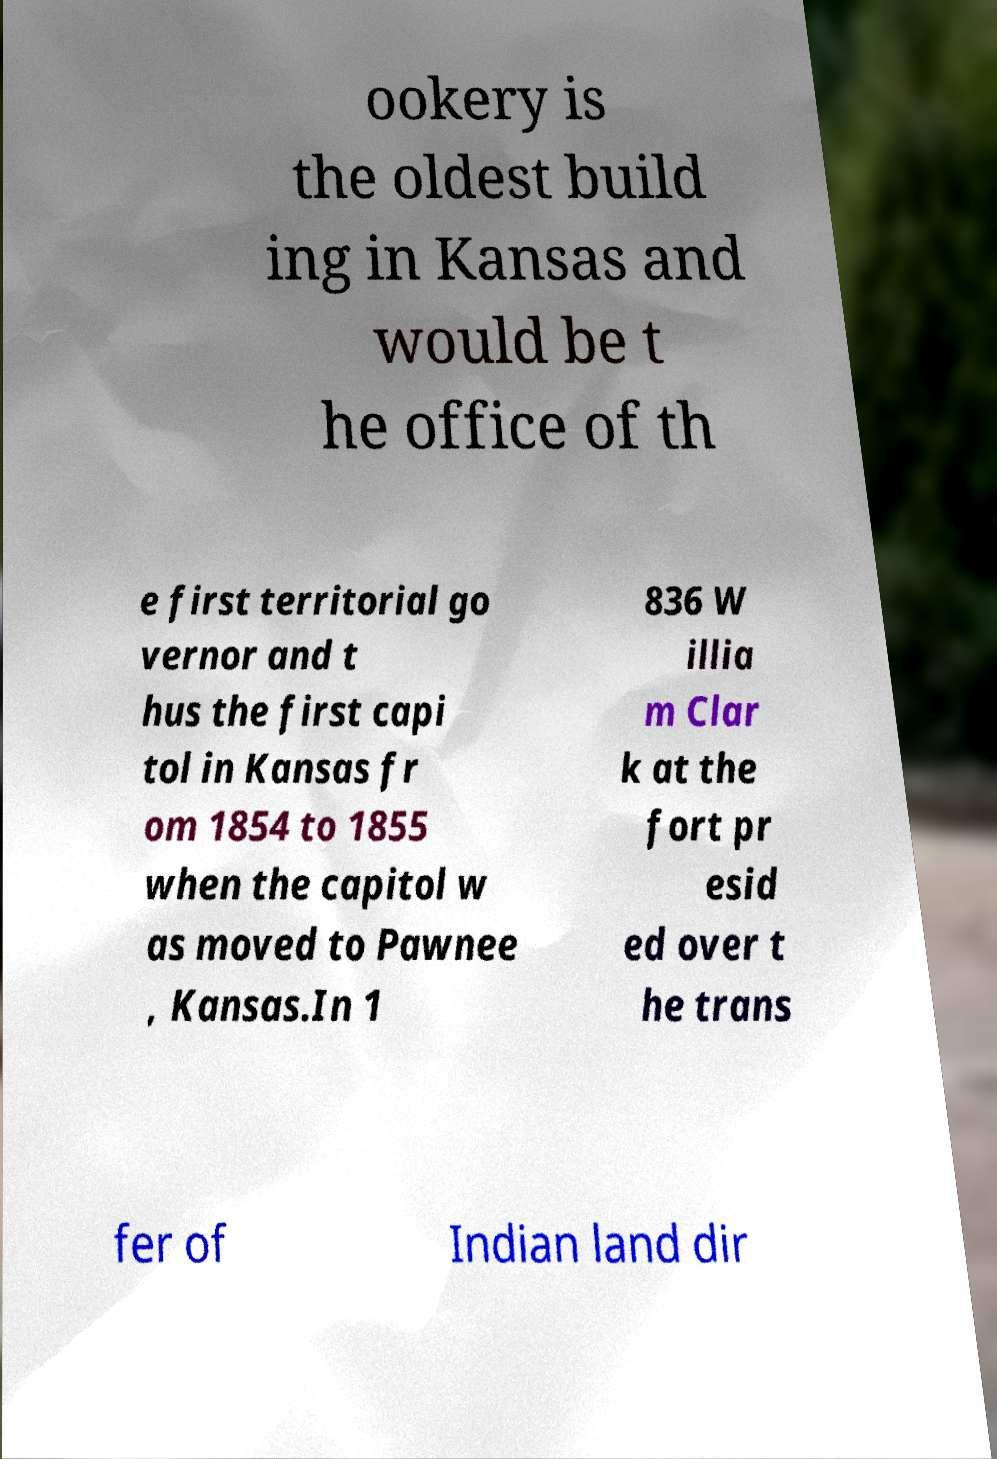Could you extract and type out the text from this image? ookery is the oldest build ing in Kansas and would be t he office of th e first territorial go vernor and t hus the first capi tol in Kansas fr om 1854 to 1855 when the capitol w as moved to Pawnee , Kansas.In 1 836 W illia m Clar k at the fort pr esid ed over t he trans fer of Indian land dir 